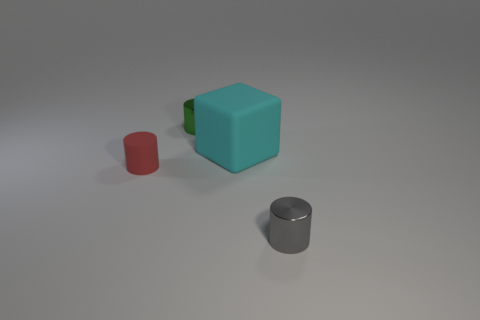Does the matte cylinder have the same color as the matte block?
Provide a short and direct response. No. What number of objects are small metallic things or matte things that are right of the small red cylinder?
Give a very brief answer. 3. Are there any red cylinders that have the same size as the green metal thing?
Give a very brief answer. Yes. Does the small gray cylinder have the same material as the cyan cube?
Your answer should be compact. No. What number of things are green metallic objects or red metallic cylinders?
Offer a terse response. 1. The matte block is what size?
Your answer should be very brief. Large. Are there fewer small things than tiny purple objects?
Ensure brevity in your answer.  No. Does the thing that is left of the tiny green cylinder have the same color as the rubber block?
Your answer should be compact. No. What shape is the tiny object behind the rubber cylinder?
Your answer should be very brief. Cylinder. Is there a small shiny thing left of the object that is in front of the red rubber cylinder?
Your response must be concise. Yes. 